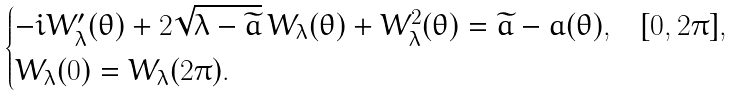<formula> <loc_0><loc_0><loc_500><loc_500>\begin{cases} - i W _ { \lambda } ^ { \prime } ( \theta ) + 2 \sqrt { \lambda - \widetilde { a } } \, W _ { \lambda } ( \theta ) + W _ { \lambda } ^ { 2 } ( \theta ) = \widetilde { a } - a ( \theta ) , & [ 0 , 2 \pi ] , \\ W _ { \lambda } ( 0 ) = W _ { \lambda } ( 2 \pi ) . & \end{cases}</formula> 